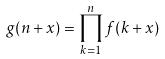Convert formula to latex. <formula><loc_0><loc_0><loc_500><loc_500>g ( n + x ) = \prod _ { k = 1 } ^ { n } f ( k + x )</formula> 